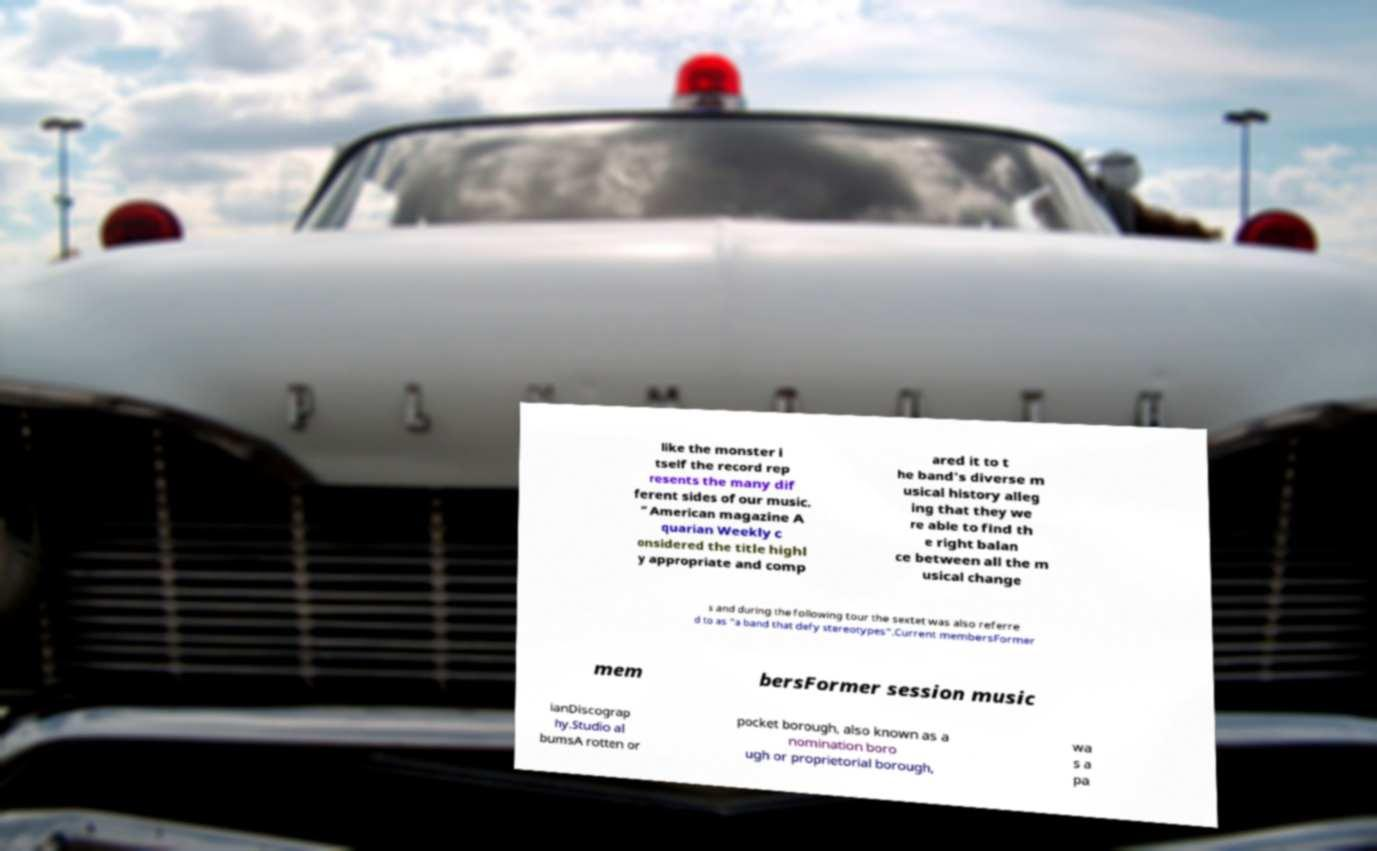What messages or text are displayed in this image? I need them in a readable, typed format. like the monster i tself the record rep resents the many dif ferent sides of our music. ” American magazine A quarian Weekly c onsidered the title highl y appropriate and comp ared it to t he band's diverse m usical history alleg ing that they we re able to find th e right balan ce between all the m usical change s and during the following tour the sextet was also referre d to as "a band that defy stereotypes".Current membersFormer mem bersFormer session music ianDiscograp hy.Studio al bumsA rotten or pocket borough, also known as a nomination boro ugh or proprietorial borough, wa s a pa 